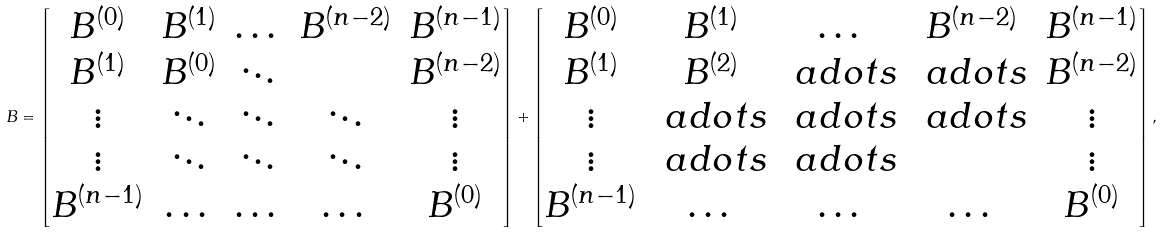<formula> <loc_0><loc_0><loc_500><loc_500>B = \begin{bmatrix} B ^ { ( 0 ) } & B ^ { ( 1 ) } & \dots & B ^ { ( n - 2 ) } & B ^ { ( n - 1 ) } \\ B ^ { ( 1 ) } & B ^ { ( 0 ) } & \ddots & & B ^ { ( n - 2 ) } \\ \vdots & \ddots & \ddots & \ddots & \vdots \\ \vdots & \ddots & \ddots & \ddots & \vdots \\ B ^ { ( n - 1 ) } & \dots & \dots & \dots & B ^ { ( 0 ) } \end{bmatrix} + \begin{bmatrix} B ^ { ( 0 ) } & B ^ { ( 1 ) } & \dots & B ^ { ( n - 2 ) } & B ^ { ( n - 1 ) } \\ B ^ { ( 1 ) } & B ^ { ( 2 ) } & \ a d o t s & \ a d o t s & B ^ { ( n - 2 ) } \\ \vdots & \ a d o t s & \ a d o t s & \ a d o t s & \vdots \\ \vdots & \ a d o t s & \ a d o t s & & \vdots \\ B ^ { ( n - 1 ) } & \dots & \dots & \dots & B ^ { ( 0 ) } \end{bmatrix} ,</formula> 